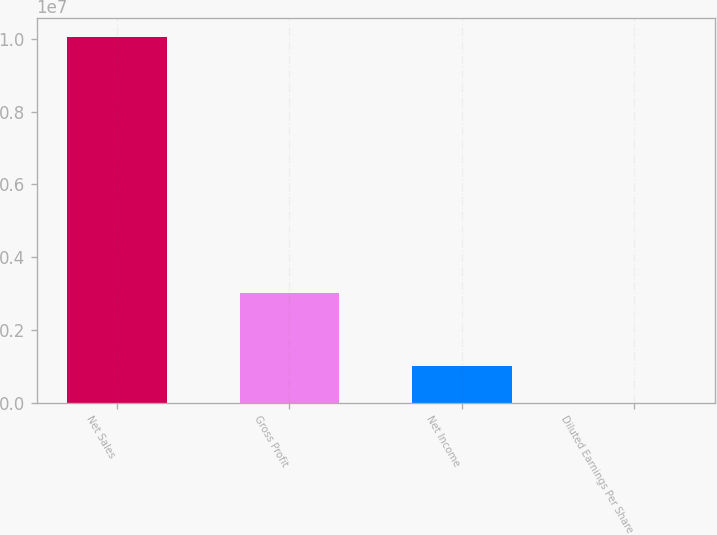Convert chart to OTSL. <chart><loc_0><loc_0><loc_500><loc_500><bar_chart><fcel>Net Sales<fcel>Gross Profit<fcel>Net Income<fcel>Diluted Earnings Per Share<nl><fcel>1.00575e+07<fcel>3.00976e+06<fcel>1.00575e+06<fcel>2.5<nl></chart> 